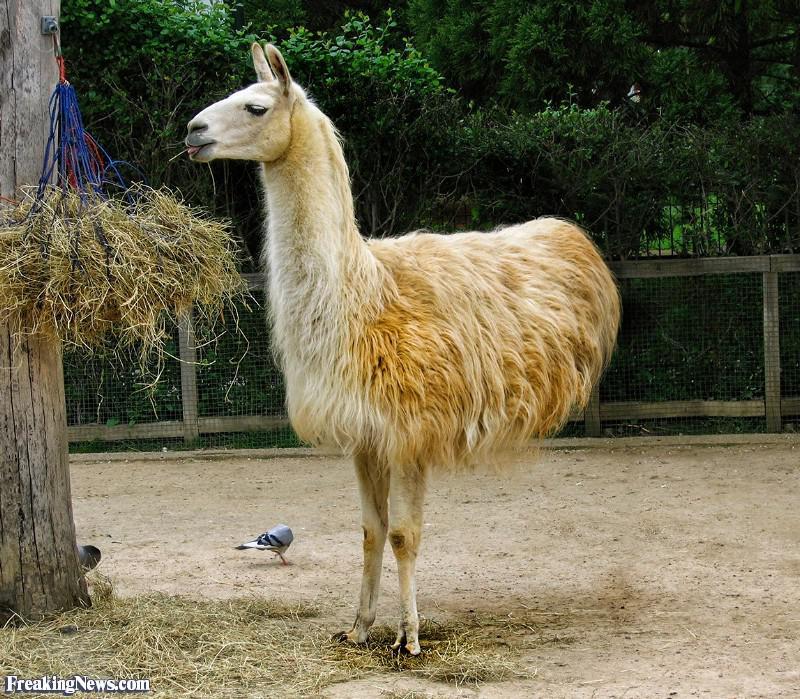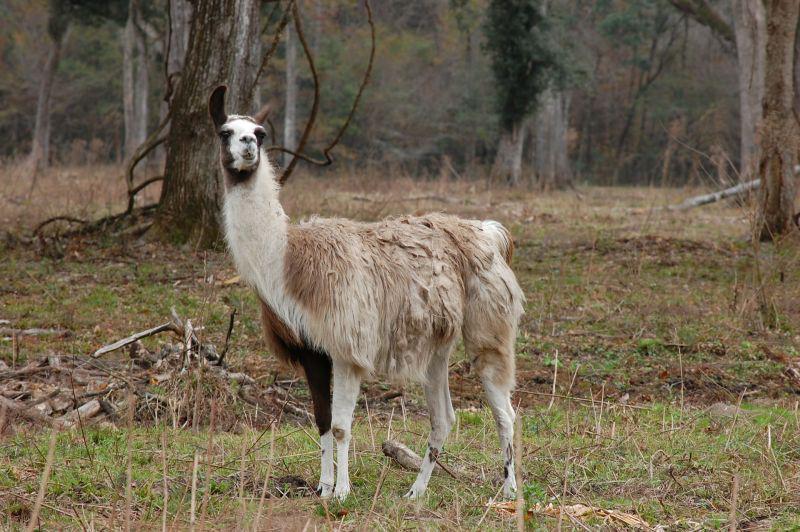The first image is the image on the left, the second image is the image on the right. Considering the images on both sides, is "In at least one image there is a baby white llama to the side of its brown mother." valid? Answer yes or no. No. The first image is the image on the left, the second image is the image on the right. Considering the images on both sides, is "The right image includes a small white llama bending its neck toward a bigger shaggy reddish-brown llama." valid? Answer yes or no. No. 